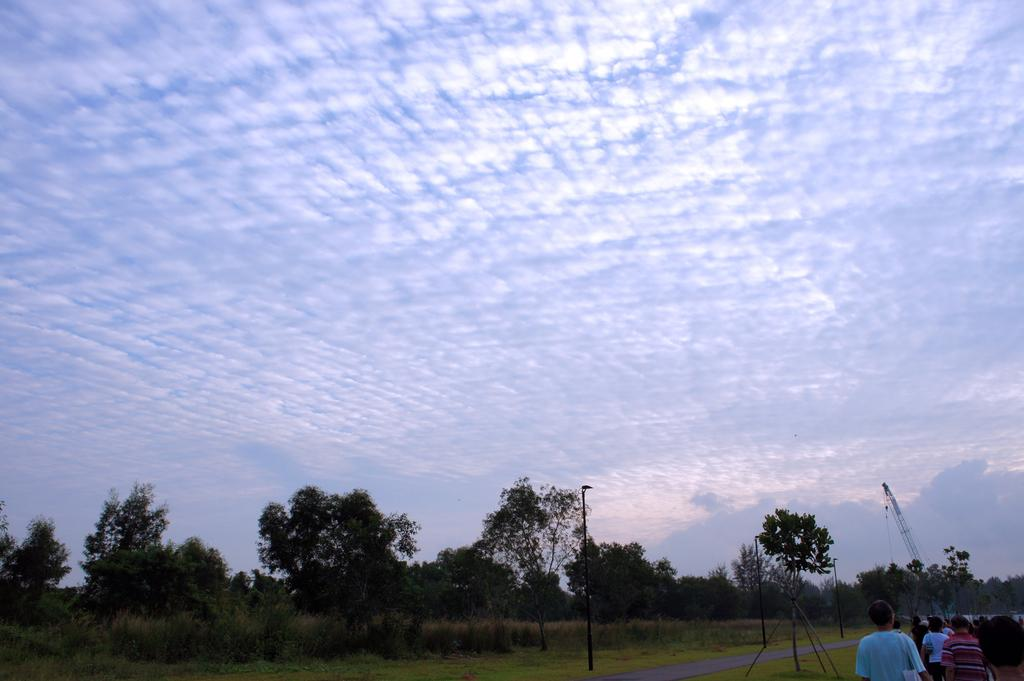What is the main feature of the image? There is a road in the image. Are there any people present in the image? Yes, there are people standing in the image. What can be seen illuminating the scene in the image? There are lights visible in the image. What type of natural environment is present in the image? There is grass and trees in the image. What is visible in the sky in the image? There are clouds in the sky. What type of thread is being used to hold the berries in the image? There are no berries or thread present in the image. What type of harbor can be seen in the image? There is no harbor present in the image. 